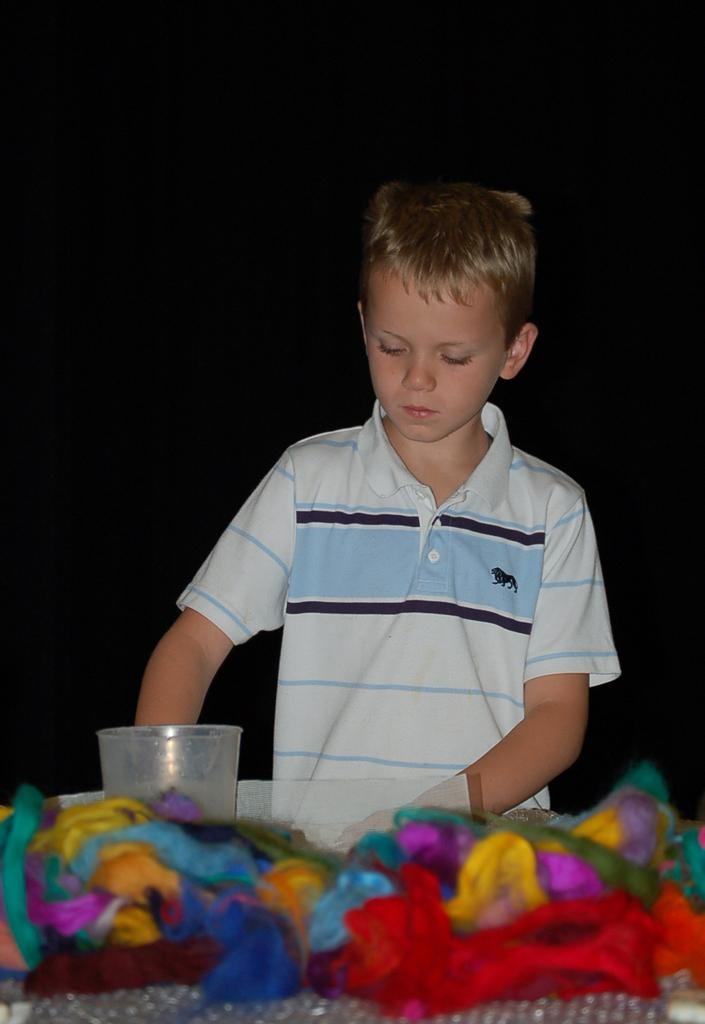Who is the main subject in the image? There is a boy in the image. What type of objects can be seen in the image? There are colorful objects in the image. What material is present in the image? There is glass in the image. Where are the colorful objects and glass located in the image? The bottom of the image contains colorful objects and glass. How would you describe the overall appearance of the image? The background of the image is dark. What memory does the boy have of saying good-bye in the image? There is no indication of a memory or the boy saying good-bye in the image. 